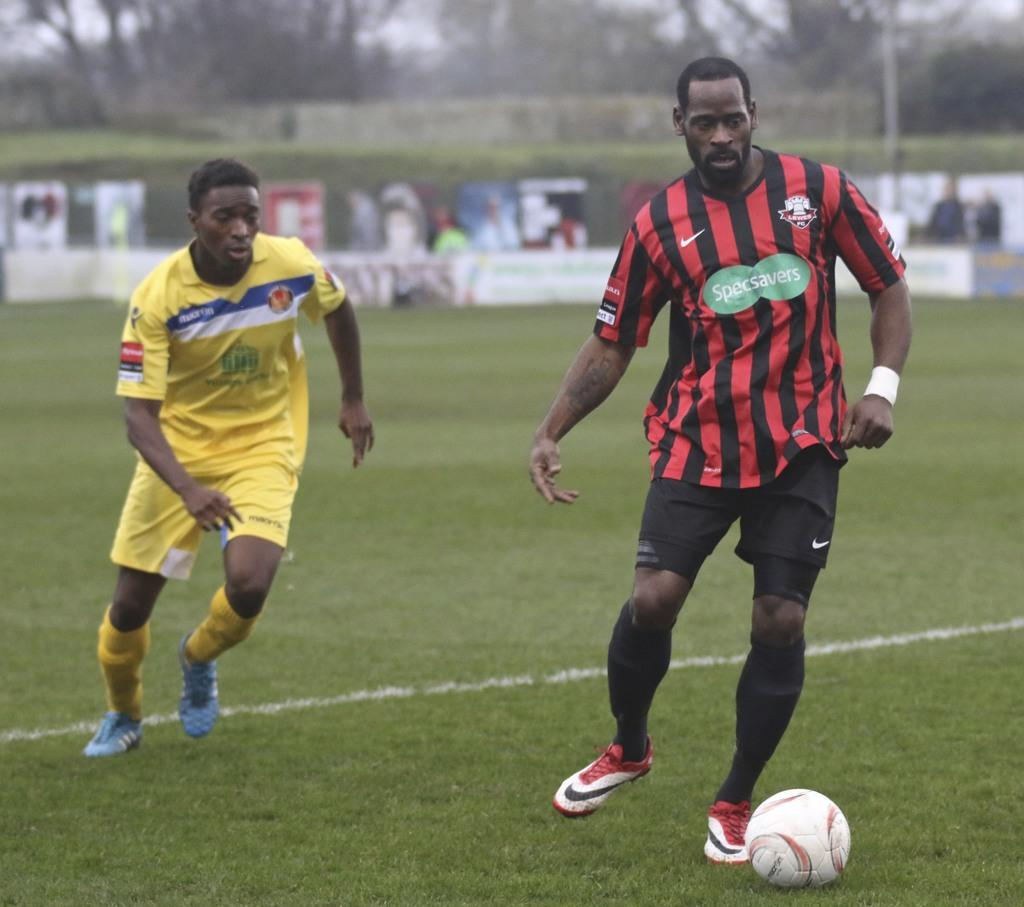<image>
Summarize the visual content of the image. The green ad on the jersey is Specsavers 